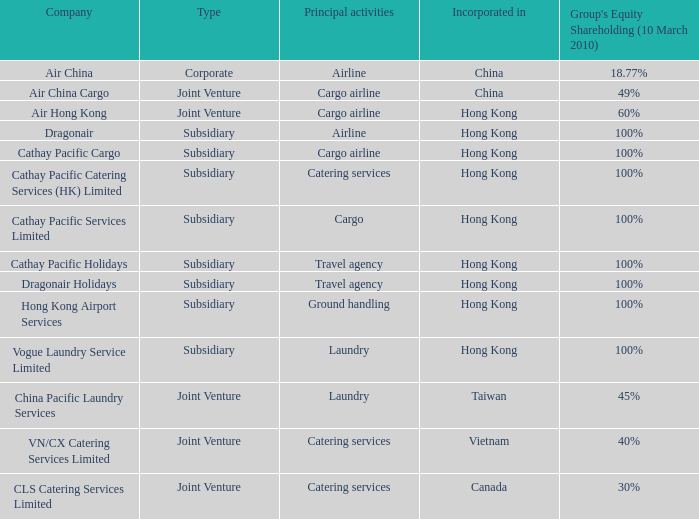Which firm's classification is joint venture, and has main activities mentioned as cargo airline and an incorporation of china? Air China Cargo. 